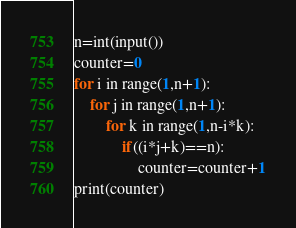<code> <loc_0><loc_0><loc_500><loc_500><_Python_>n=int(input())
counter=0
for i in range(1,n+1):
    for j in range(1,n+1):
        for k in range(1,n-i*k):
            if((i*j+k)==n):
                counter=counter+1
print(counter)</code> 